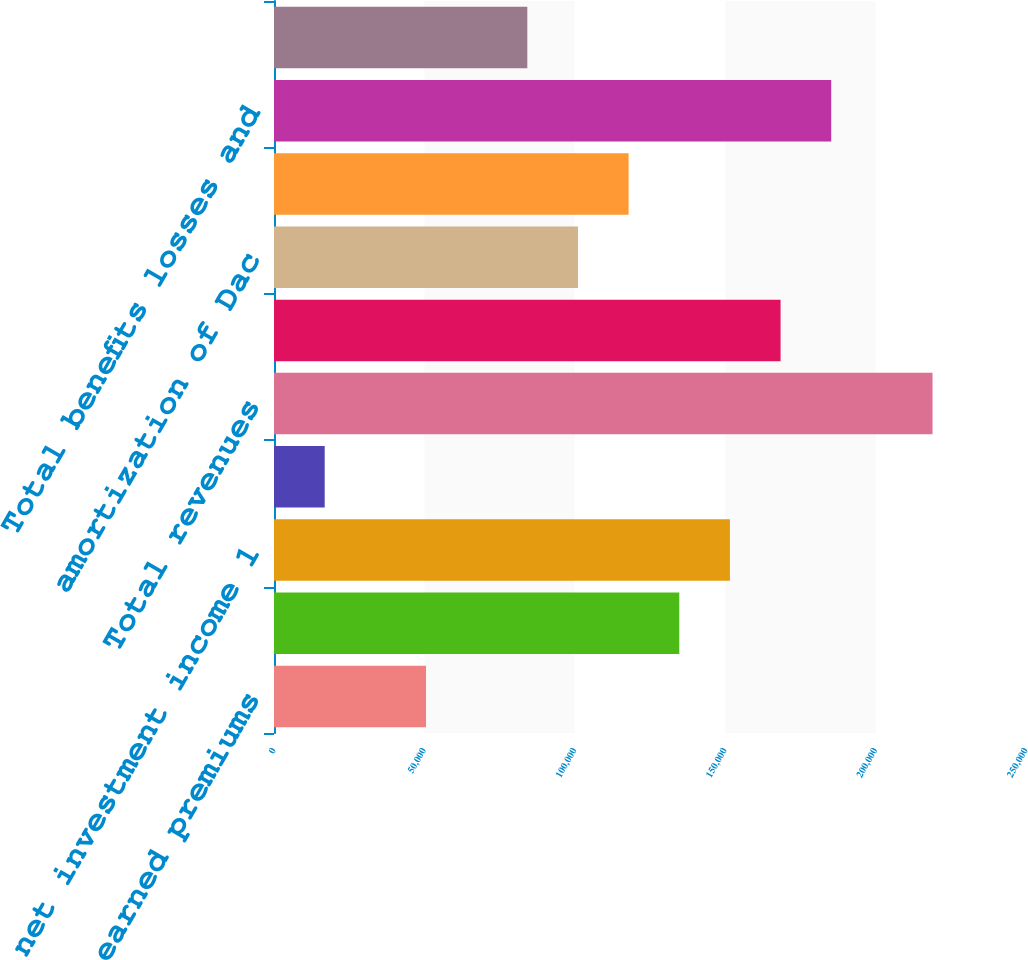Convert chart to OTSL. <chart><loc_0><loc_0><loc_500><loc_500><bar_chart><fcel>earned premiums<fcel>fee income and other<fcel>net investment income 1<fcel>net realized capital (losses)<fcel>Total revenues<fcel>Benefits losses and loss<fcel>amortization of Dac<fcel>insurance operating costs and<fcel>Total benefits losses and<fcel>Income from continuing<nl><fcel>50533.6<fcel>134730<fcel>151569<fcel>16855.2<fcel>218926<fcel>168408<fcel>101051<fcel>117890<fcel>185247<fcel>84212<nl></chart> 